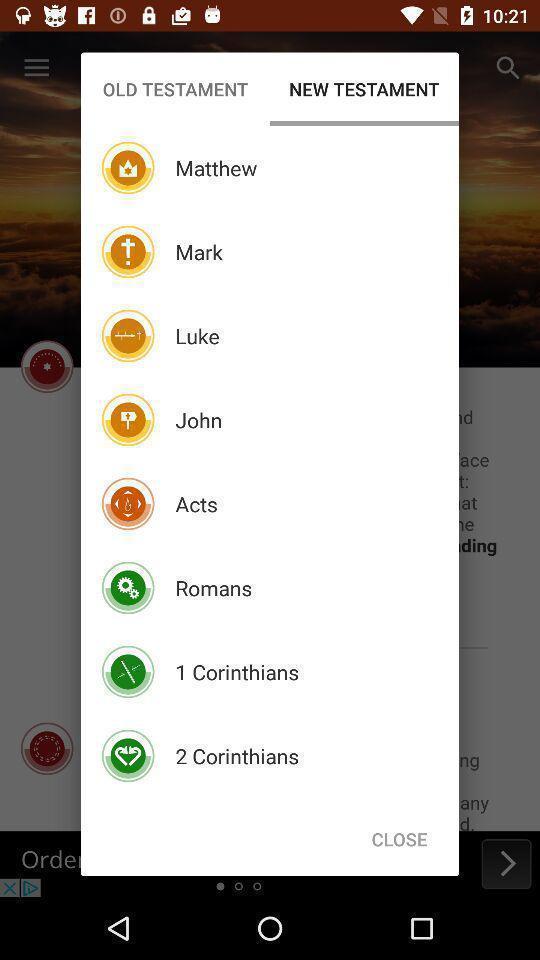Describe the content in this image. Pop-up to select references in the religious book application. 